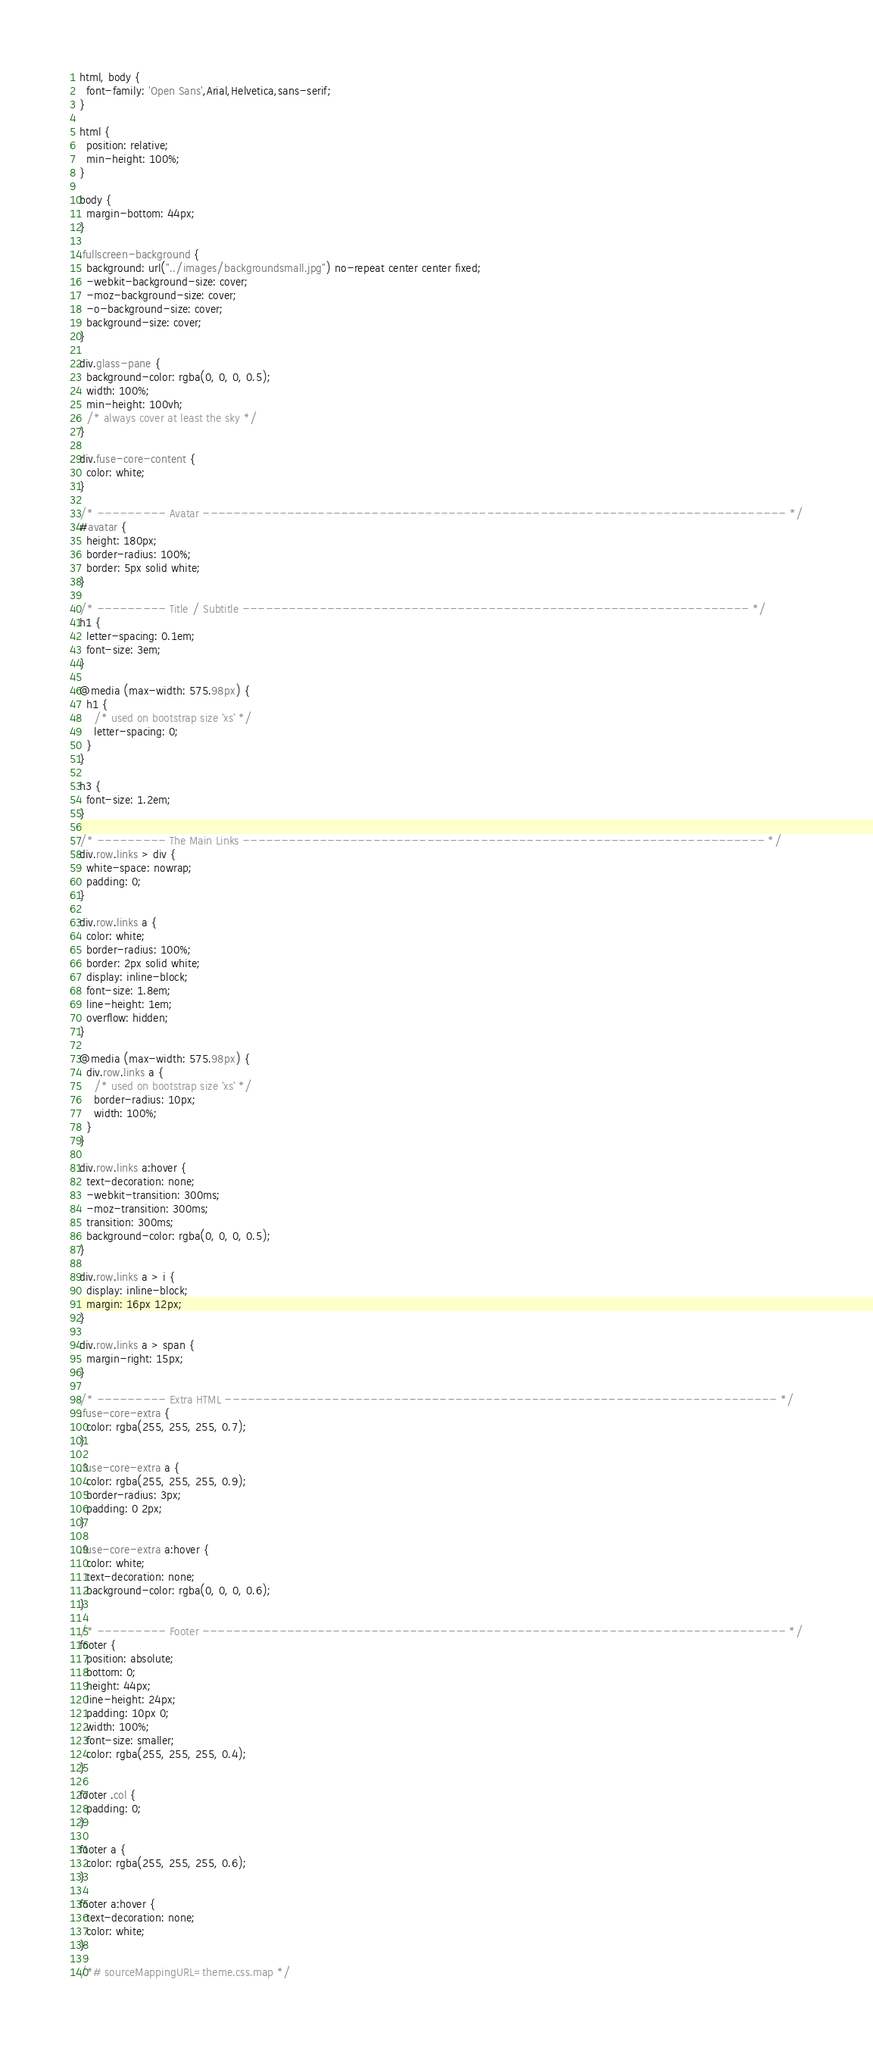Convert code to text. <code><loc_0><loc_0><loc_500><loc_500><_CSS_>html, body {
  font-family: 'Open Sans',Arial,Helvetica,sans-serif;
}

html {
  position: relative;
  min-height: 100%;
}

body {
  margin-bottom: 44px;
}

.fullscreen-background {
  background: url("../images/backgroundsmall.jpg") no-repeat center center fixed;
  -webkit-background-size: cover;
  -moz-background-size: cover;
  -o-background-size: cover;
  background-size: cover;
}

div.glass-pane {
  background-color: rgba(0, 0, 0, 0.5);
  width: 100%;
  min-height: 100vh;
  /* always cover at least the sky */
}

div.fuse-core-content {
  color: white;
}

/* --------- Avatar ---------------------------------------------------------------------------- */
#avatar {
  height: 180px;
  border-radius: 100%;
  border: 5px solid white;
}

/* --------- Title / Subtitle ------------------------------------------------------------------ */
h1 {
  letter-spacing: 0.1em;
  font-size: 3em;
}

@media (max-width: 575.98px) {
  h1 {
    /* used on bootstrap size 'xs' */
    letter-spacing: 0;
  }
}

h3 {
  font-size: 1.2em;
}

/* --------- The Main Links -------------------------------------------------------------------- */
div.row.links > div {
  white-space: nowrap;
  padding: 0;
}

div.row.links a {
  color: white;
  border-radius: 100%;
  border: 2px solid white;
  display: inline-block;
  font-size: 1.8em;
  line-height: 1em;
  overflow: hidden;
}

@media (max-width: 575.98px) {
  div.row.links a {
    /* used on bootstrap size 'xs' */
    border-radius: 10px;
    width: 100%;
  }
}

div.row.links a:hover {
  text-decoration: none;
  -webkit-transition: 300ms;
  -moz-transition: 300ms;
  transition: 300ms;
  background-color: rgba(0, 0, 0, 0.5);
}

div.row.links a > i {
  display: inline-block;
  margin: 16px 12px;
}

div.row.links a > span {
  margin-right: 15px;
}

/* --------- Extra HTML ------------------------------------------------------------------------ */
.fuse-core-extra {
  color: rgba(255, 255, 255, 0.7);
}

.fuse-core-extra a {
  color: rgba(255, 255, 255, 0.9);
  border-radius: 3px;
  padding: 0 2px;
}

.fuse-core-extra a:hover {
  color: white;
  text-decoration: none;
  background-color: rgba(0, 0, 0, 0.6);
}

/* --------- Footer ---------------------------------------------------------------------------- */
footer {
  position: absolute;
  bottom: 0;
  height: 44px;
  line-height: 24px;
  padding: 10px 0;
  width: 100%;
  font-size: smaller;
  color: rgba(255, 255, 255, 0.4);
}

footer .col {
  padding: 0;
}

footer a {
  color: rgba(255, 255, 255, 0.6);
}

footer a:hover {
  text-decoration: none;
  color: white;
}

/*# sourceMappingURL=theme.css.map */</code> 